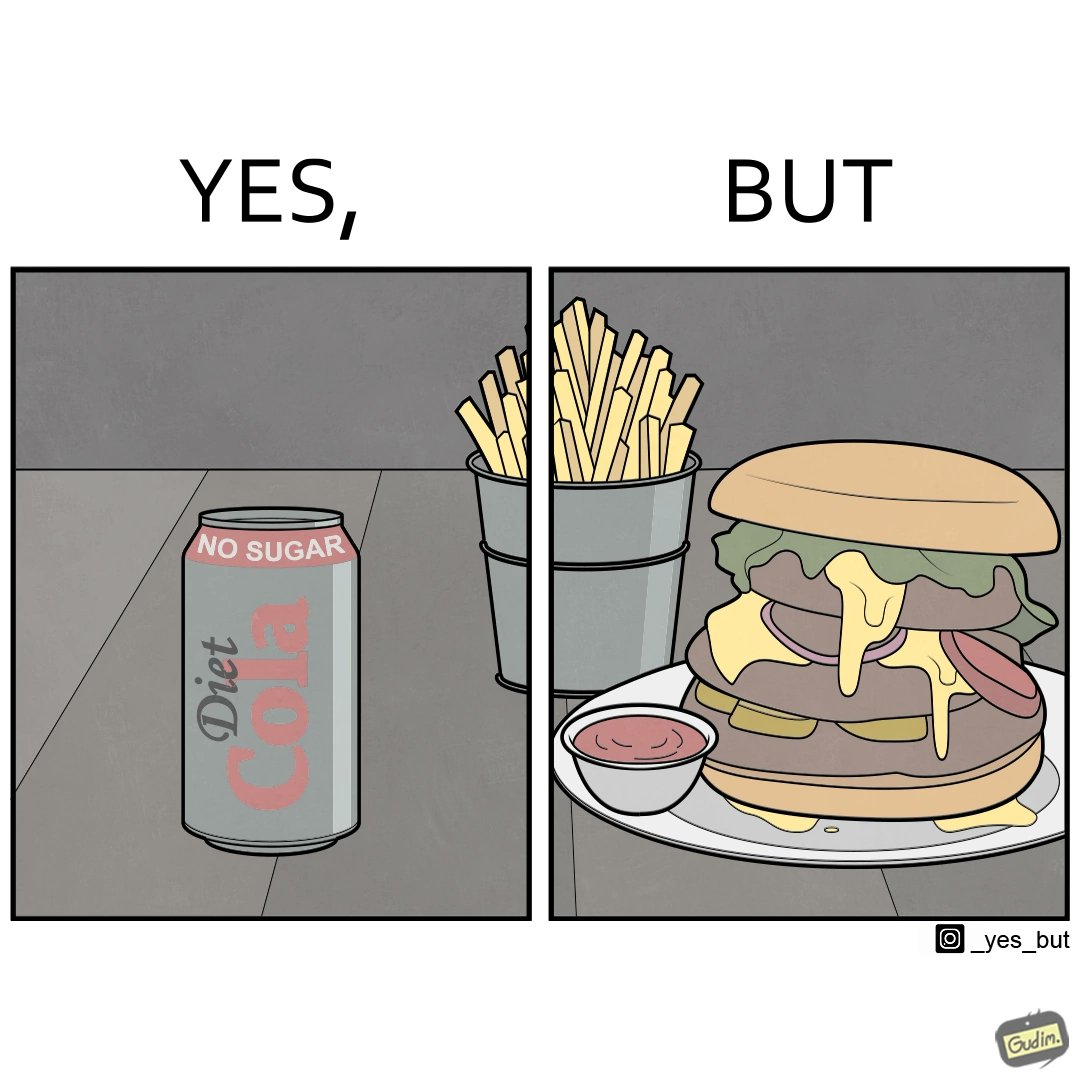Describe the contrast between the left and right parts of this image. In the left part of the image: a cold drink can, named by diet cola, with french fries at the back In the right part of the image: a huge size burger with french fries 